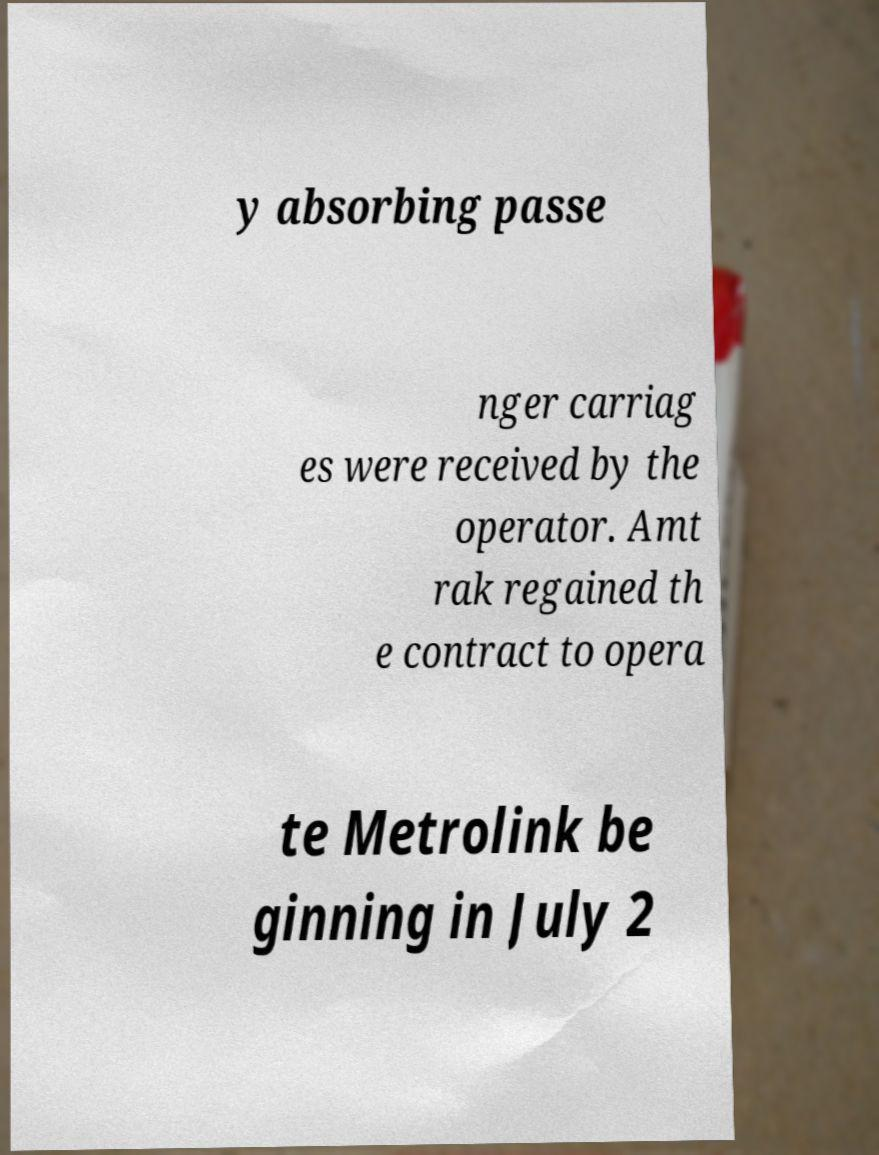What messages or text are displayed in this image? I need them in a readable, typed format. y absorbing passe nger carriag es were received by the operator. Amt rak regained th e contract to opera te Metrolink be ginning in July 2 